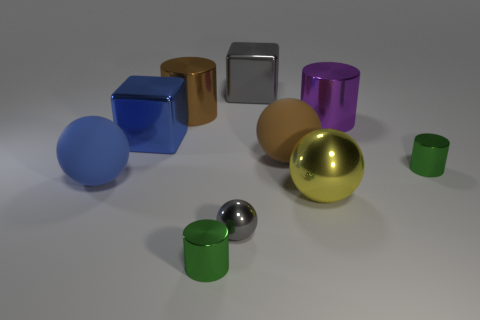The gray block is what size?
Offer a very short reply. Large. What color is the other small sphere that is the same material as the yellow sphere?
Offer a terse response. Gray. How many blue spheres are made of the same material as the gray ball?
Provide a succinct answer. 0. How many things are either gray balls or matte spheres behind the blue rubber ball?
Your answer should be compact. 2. Is the material of the gray object in front of the blue cube the same as the gray cube?
Your answer should be compact. Yes. What color is the other metal cylinder that is the same size as the purple cylinder?
Your answer should be very brief. Brown. Is there a blue thing of the same shape as the yellow metal object?
Offer a terse response. Yes. What is the color of the big ball behind the green thing behind the green object that is in front of the big yellow shiny thing?
Your answer should be very brief. Brown. What number of matte things are big blocks or small brown things?
Ensure brevity in your answer.  0. Is the number of big cylinders that are left of the yellow metallic sphere greater than the number of large cylinders left of the blue metallic block?
Provide a succinct answer. Yes. 